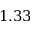Convert formula to latex. <formula><loc_0><loc_0><loc_500><loc_500>1 . 3 3</formula> 